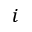Convert formula to latex. <formula><loc_0><loc_0><loc_500><loc_500>i</formula> 